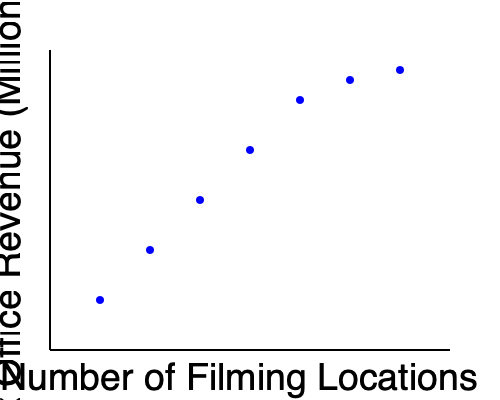Based on the scatter plot showing the relationship between the number of filming locations and box office revenue for a set of films, what trend can be observed? How might this trend be explained from a film critic's perspective? To answer this question, let's analyze the scatter plot step-by-step:

1. Observe the general trend: As we move from left to right (increasing number of filming locations), the points tend to move upward (increasing box office revenue).

2. Relationship type: This pattern suggests a positive correlation between the number of filming locations and box office revenue.

3. Trend analysis: The relationship appears to be non-linear. The increase in revenue is more pronounced for the first few additional locations, then it starts to level off.

4. Film critic's perspective:
   a) Diverse locations can add visual interest and production value to a film, potentially attracting larger audiences.
   b) Multiple locations might indicate a higher budget, which often correlates with more extensive marketing and wider distribution.
   c) Films with more locations might offer a sense of adventure or escapism, appealing to viewers' desire for new experiences.
   d) However, the diminishing returns (leveling off) could suggest that beyond a certain point, additional locations may not significantly impact audience appeal.

5. Audience impact: As a film critic exploring location impact, one could argue that audiences are drawn to the variety and authenticity that multiple filming locations can provide, but there's a limit to this effect.

6. Industry implications: This trend might influence filmmakers' decisions on balancing the number of locations with budget constraints and storytelling needs.
Answer: Positive correlation with diminishing returns; more locations generally increase revenue, likely due to added visual appeal and production value, but with decreasing impact beyond a certain point. 